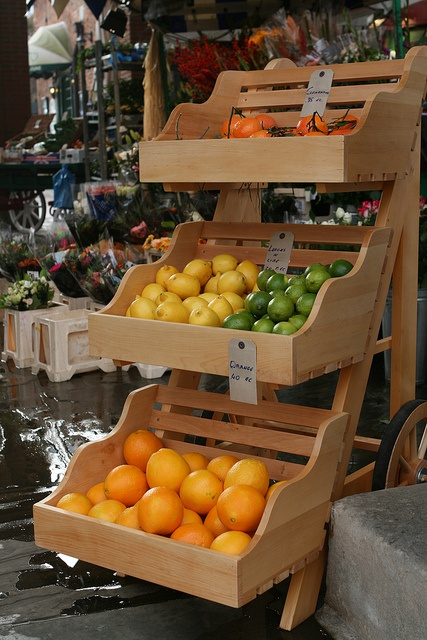Describe the objects in this image and their specific colors. I can see orange in black, orange, and red tones, orange in black, red, orange, and maroon tones, orange in black, red, orange, and brown tones, and orange in black, red, orange, and maroon tones in this image. 